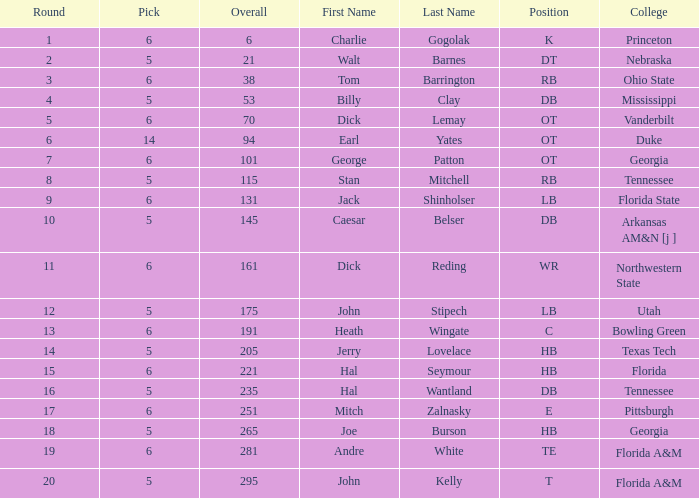What is Pick, when Round is 15? 6.0. 